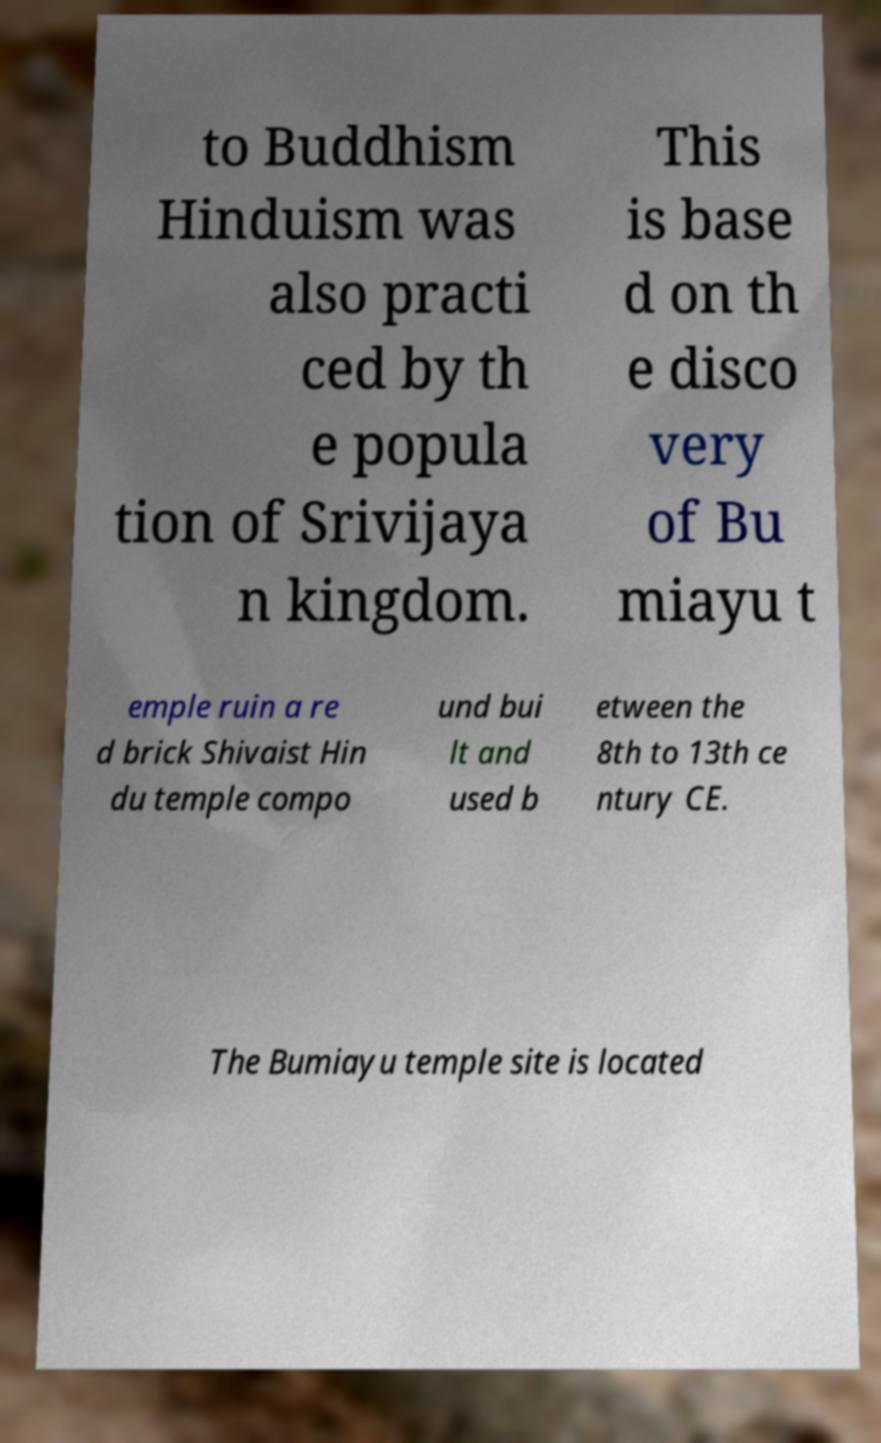Please identify and transcribe the text found in this image. to Buddhism Hinduism was also practi ced by th e popula tion of Srivijaya n kingdom. This is base d on th e disco very of Bu miayu t emple ruin a re d brick Shivaist Hin du temple compo und bui lt and used b etween the 8th to 13th ce ntury CE. The Bumiayu temple site is located 